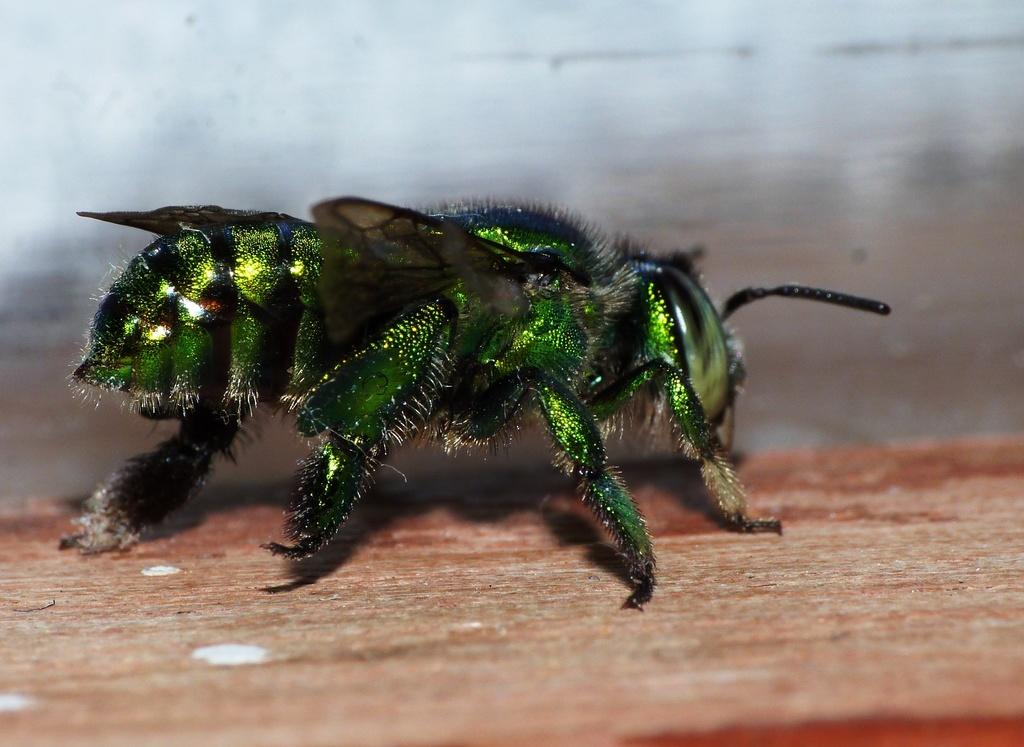What type of creature is in the foreground of the image? There is a green insect in the foreground of the image. What surface is the insect on? The insect is on a wooden surface. Can you describe the background of the image? The background of the image is blurred. What type of nail is the insect using to climb the wooden surface in the image? There is no nail present in the image, and the insect is not using any tool to climb the wooden surface. 